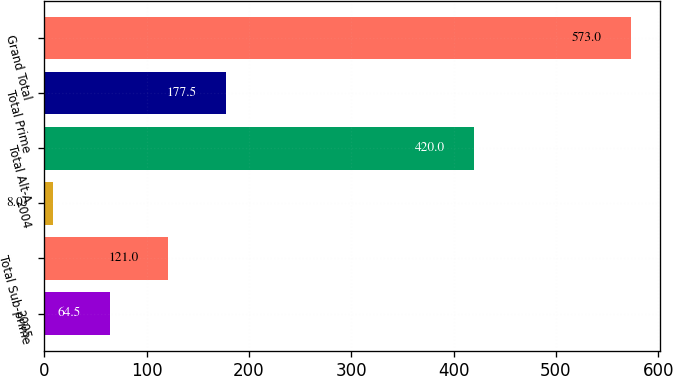<chart> <loc_0><loc_0><loc_500><loc_500><bar_chart><fcel>2005<fcel>Total Sub-prime<fcel>2004<fcel>Total Alt-A<fcel>Total Prime<fcel>Grand Total<nl><fcel>64.5<fcel>121<fcel>8<fcel>420<fcel>177.5<fcel>573<nl></chart> 